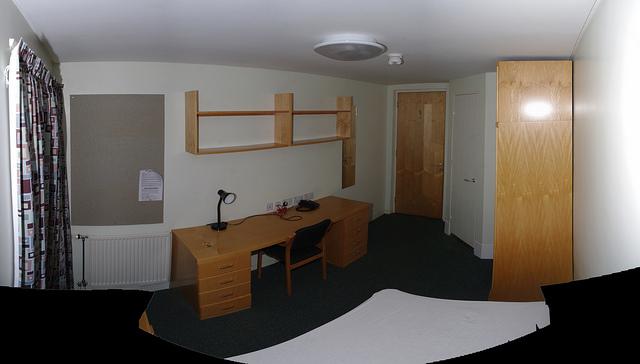Is there a wood desk in the room?
Answer briefly. Yes. How many doors are in this room?
Give a very brief answer. 2. Is there a bulletin board?
Quick response, please. Yes. 